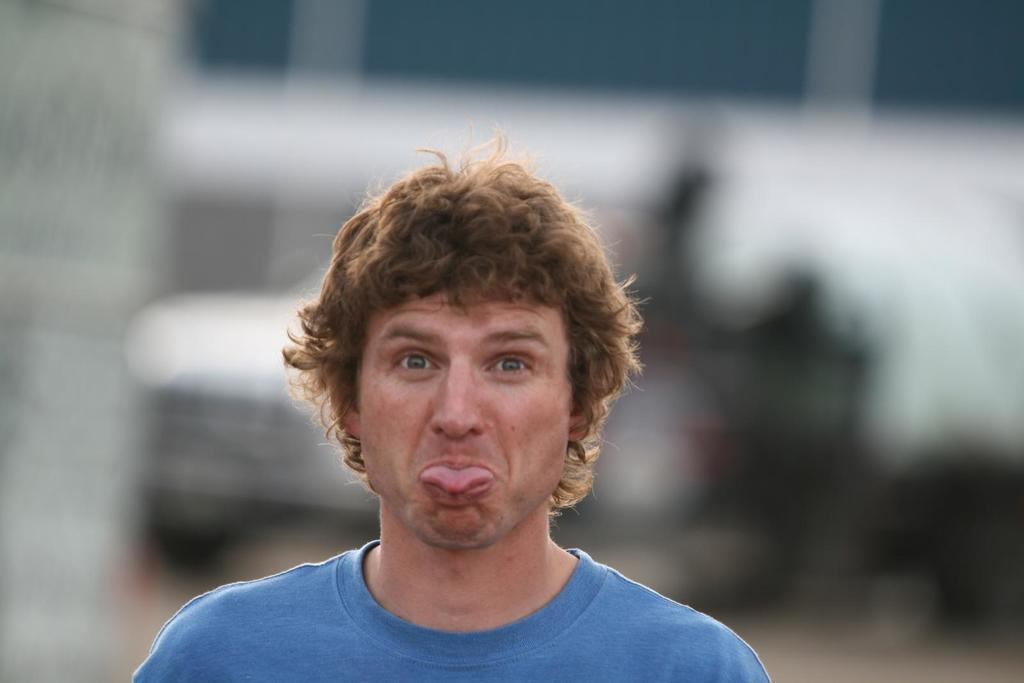Who is the main subject in the image? There is a man in the center of the image. What is the man wearing? The man is wearing a blue t-shirt. Can you describe the background of the image? The background of the image is blurry. What type of furniture is the man sitting on in the image? There is no furniture visible in the image; the man is standing. Is the man crying in the image? There is no indication in the image that the man is crying. 